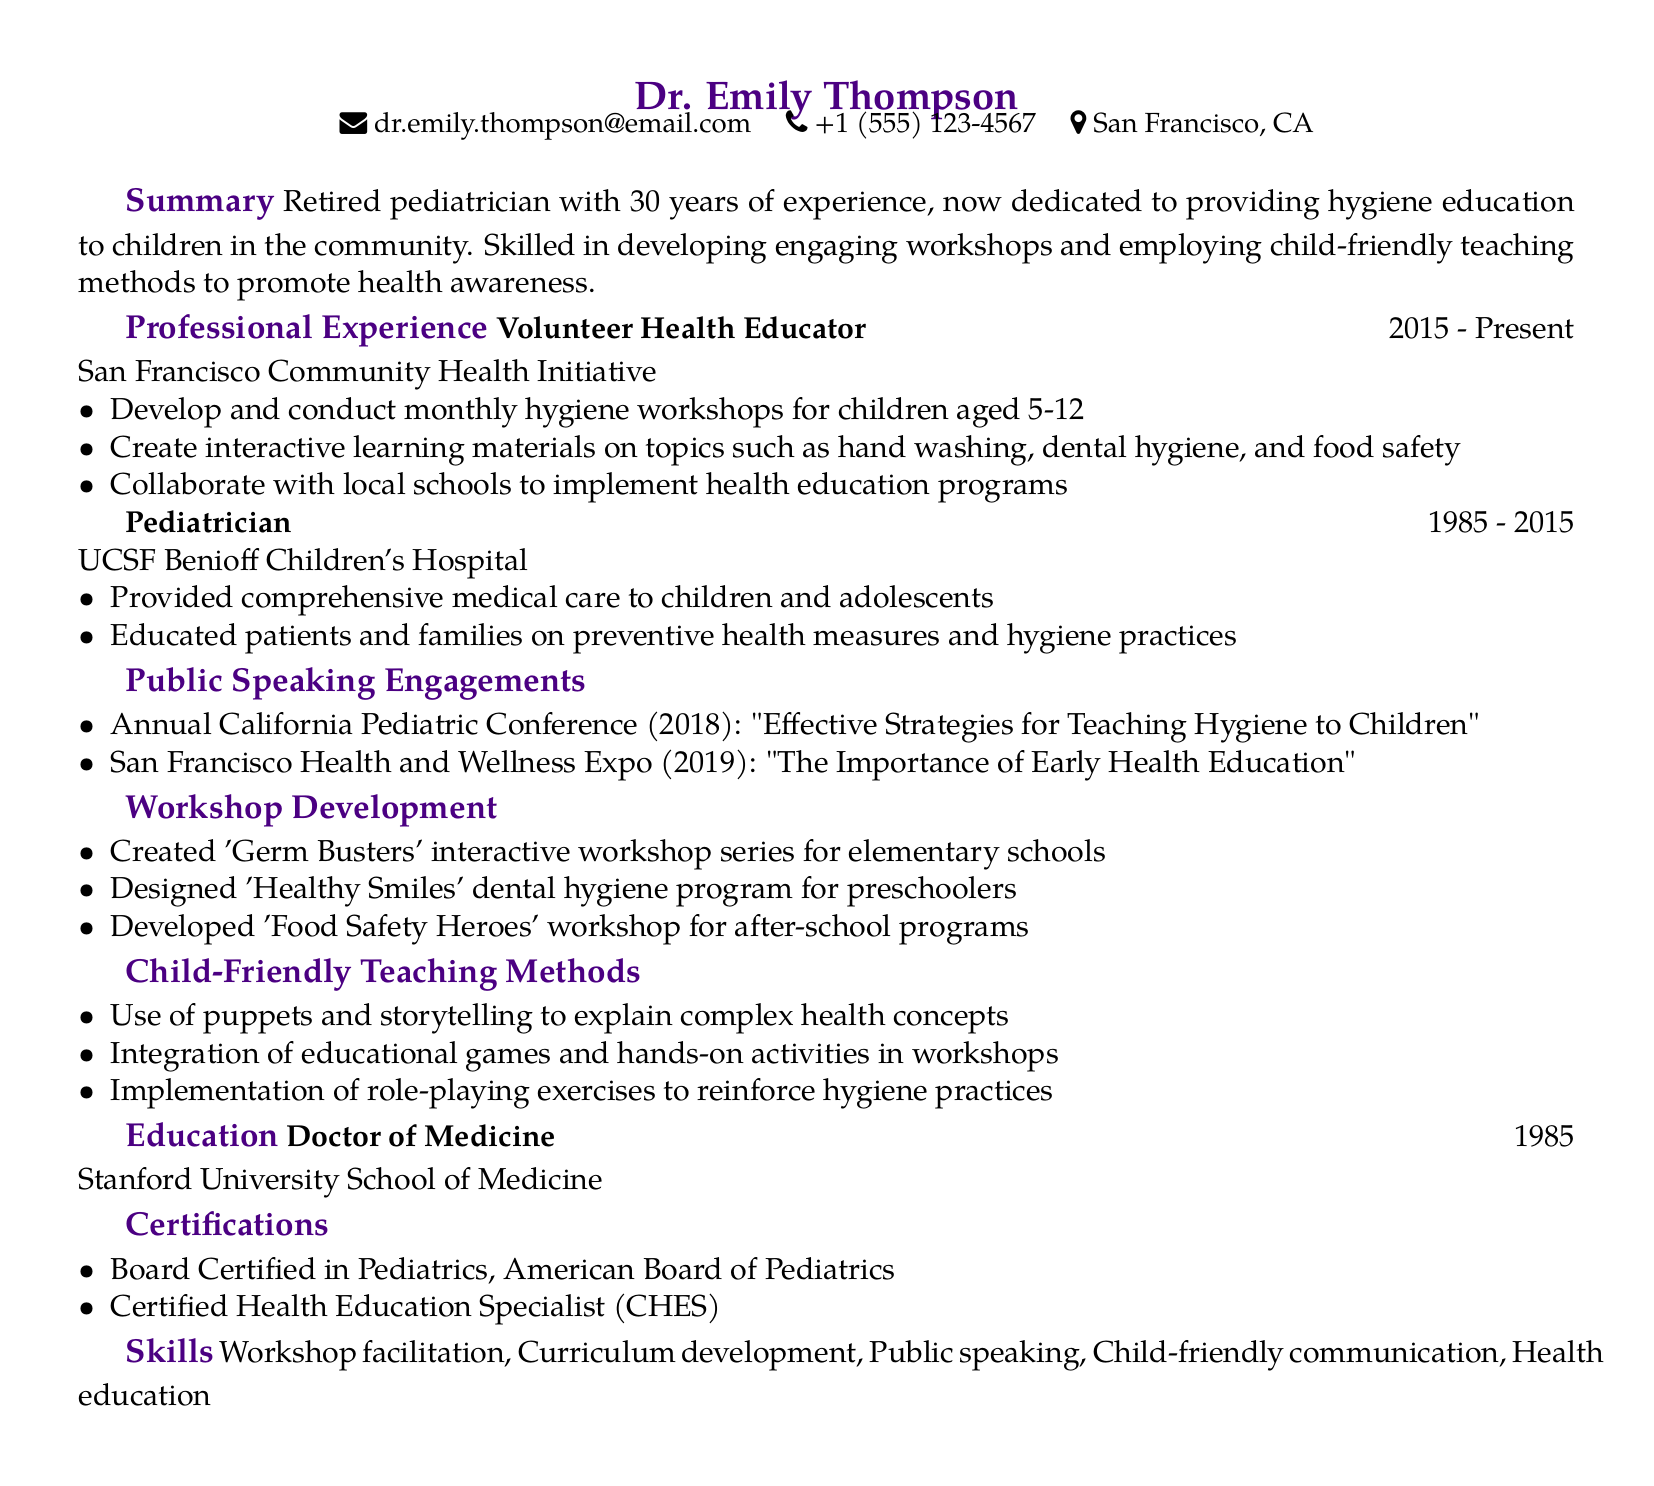What is the name of the volunteer organization? The document mentions that Dr. Emily Thompson volunteers with the San Francisco Community Health Initiative.
Answer: San Francisco Community Health Initiative What was Dr. Thompson’s role at UCSF Benioff Children's Hospital? The document states that Dr. Thompson worked as a Pediatrician at UCSF Benioff Children's Hospital.
Answer: Pediatrician In which year did Dr. Thompson start volunteering? The start year for Dr. Thompson's volunteering at the Community Health Initiative is noted as 2015.
Answer: 2015 What topic did Dr. Thompson speak on at the 2018 Annual California Pediatric Conference? The document specifies the topic as "Effective Strategies for Teaching Hygiene to Children."
Answer: Effective Strategies for Teaching Hygiene to Children How many interactive workshops has Dr. Thompson created? The document lists three workshops created by Dr. Thompson.
Answer: Three What teaching method involves using puppets and storytelling? The document includes this specific method in the section on child-friendly teaching methods.
Answer: Use of puppets and storytelling What degree did Dr. Thompson earn? The document states she earned a Doctor of Medicine degree.
Answer: Doctor of Medicine What certification does Dr. Thompson hold from the American Board of Pediatrics? The document lists her as Board Certified in Pediatrics.
Answer: Board Certified in Pediatrics 